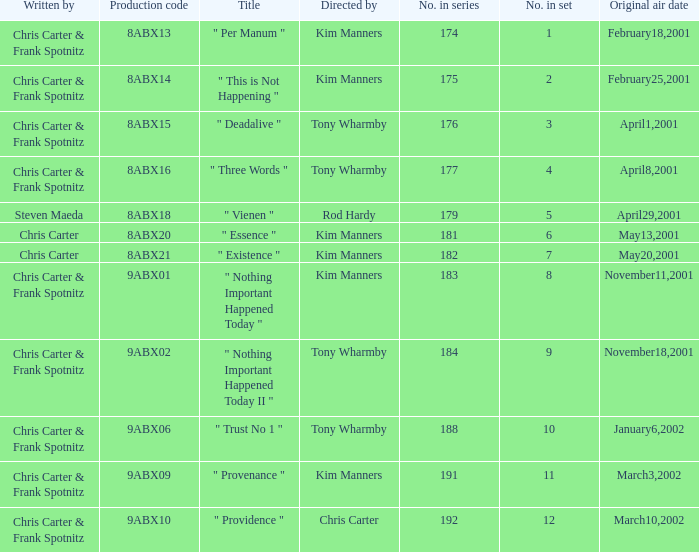The episode with production code 9abx02 was originally aired on what date? November18,2001. 